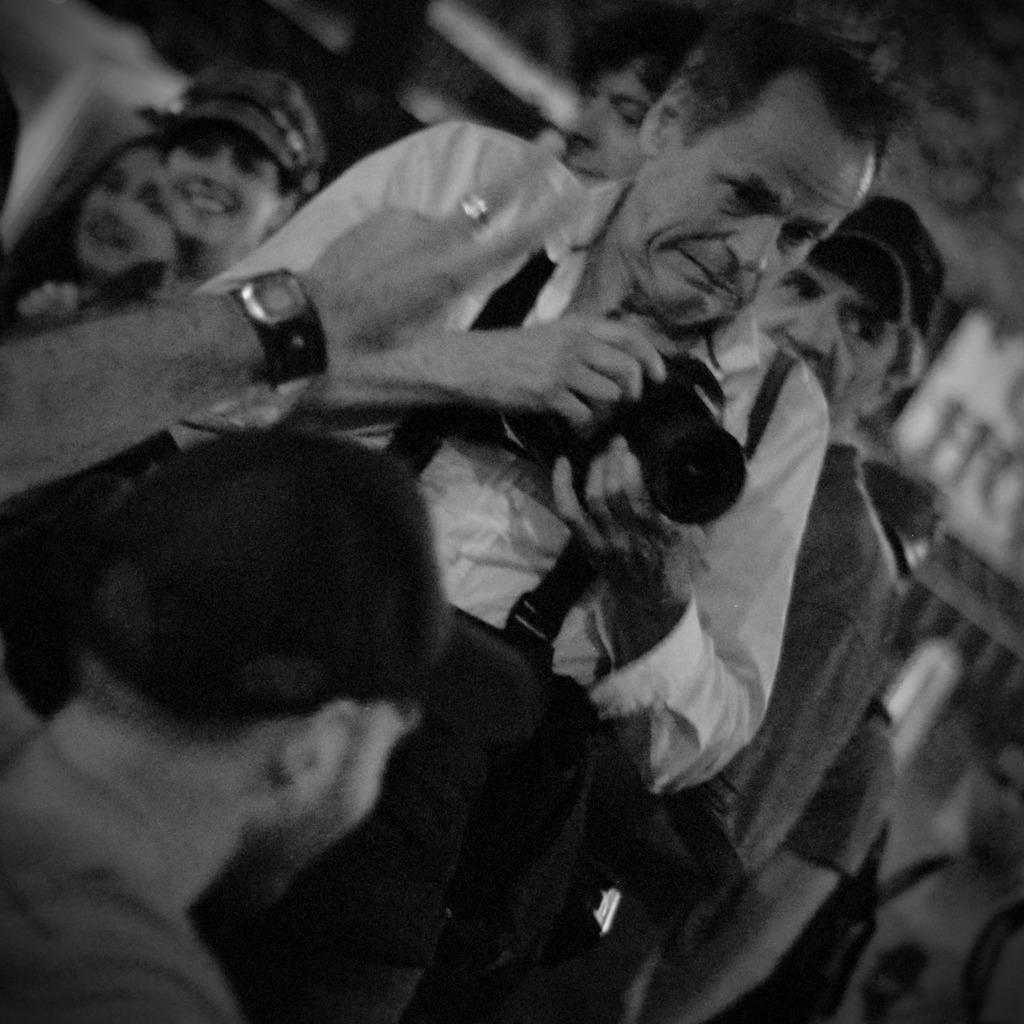Describe this image in one or two sentences. This is a black and white image where we can see a man is holding a camera. We can see one more man in the left bottom of the image. In the background, we can see people. 